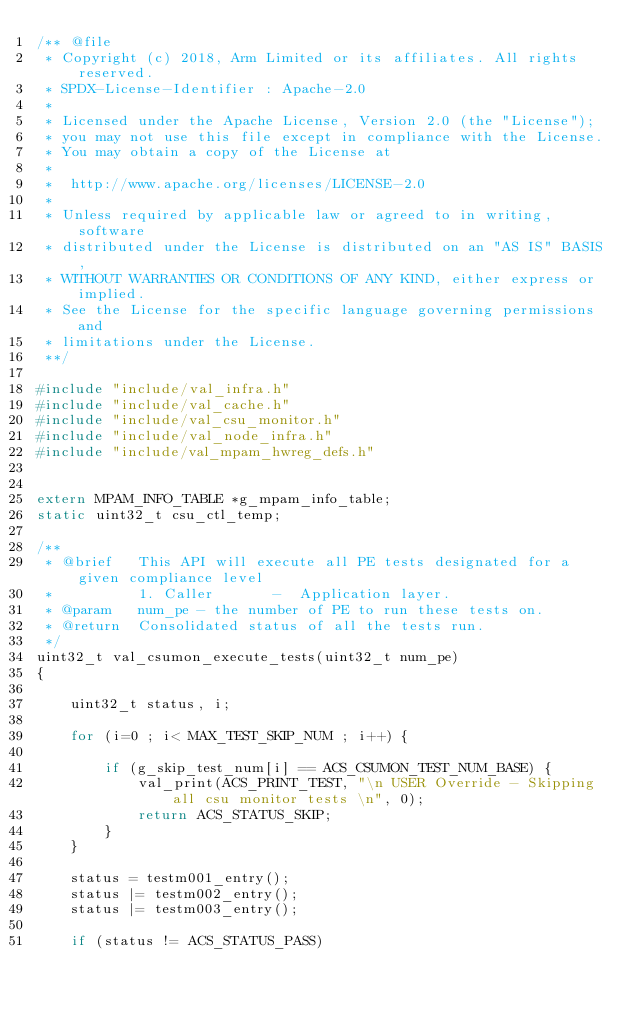Convert code to text. <code><loc_0><loc_0><loc_500><loc_500><_C_>/** @file
 * Copyright (c) 2018, Arm Limited or its affiliates. All rights reserved.
 * SPDX-License-Identifier : Apache-2.0
 *
 * Licensed under the Apache License, Version 2.0 (the "License");
 * you may not use this file except in compliance with the License.
 * You may obtain a copy of the License at
 *
 *  http://www.apache.org/licenses/LICENSE-2.0
 *
 * Unless required by applicable law or agreed to in writing, software
 * distributed under the License is distributed on an "AS IS" BASIS,
 * WITHOUT WARRANTIES OR CONDITIONS OF ANY KIND, either express or implied.
 * See the License for the specific language governing permissions and
 * limitations under the License.
 **/

#include "include/val_infra.h"
#include "include/val_cache.h"
#include "include/val_csu_monitor.h"
#include "include/val_node_infra.h"
#include "include/val_mpam_hwreg_defs.h"


extern MPAM_INFO_TABLE *g_mpam_info_table;
static uint32_t csu_ctl_temp;

/**
 * @brief   This API will execute all PE tests designated for a given compliance level
 *          1. Caller       -  Application layer.
 * @param   num_pe - the number of PE to run these tests on.
 * @return  Consolidated status of all the tests run.
 */
uint32_t val_csumon_execute_tests(uint32_t num_pe)
{

    uint32_t status, i;

    for (i=0 ; i< MAX_TEST_SKIP_NUM ; i++) {

        if (g_skip_test_num[i] == ACS_CSUMON_TEST_NUM_BASE) {
            val_print(ACS_PRINT_TEST, "\n USER Override - Skipping all csu monitor tests \n", 0);
            return ACS_STATUS_SKIP;
        }
    }

    status = testm001_entry();
    status |= testm002_entry();
    status |= testm003_entry();

    if (status != ACS_STATUS_PASS)</code> 